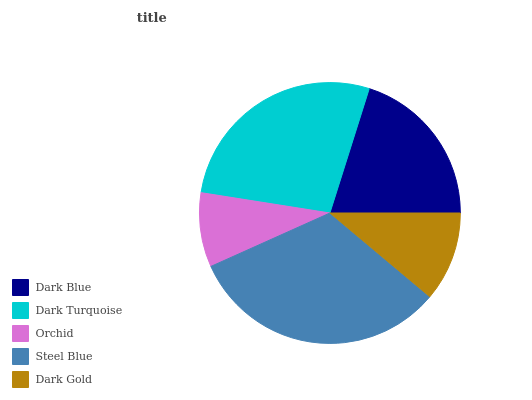Is Orchid the minimum?
Answer yes or no. Yes. Is Steel Blue the maximum?
Answer yes or no. Yes. Is Dark Turquoise the minimum?
Answer yes or no. No. Is Dark Turquoise the maximum?
Answer yes or no. No. Is Dark Turquoise greater than Dark Blue?
Answer yes or no. Yes. Is Dark Blue less than Dark Turquoise?
Answer yes or no. Yes. Is Dark Blue greater than Dark Turquoise?
Answer yes or no. No. Is Dark Turquoise less than Dark Blue?
Answer yes or no. No. Is Dark Blue the high median?
Answer yes or no. Yes. Is Dark Blue the low median?
Answer yes or no. Yes. Is Dark Gold the high median?
Answer yes or no. No. Is Orchid the low median?
Answer yes or no. No. 